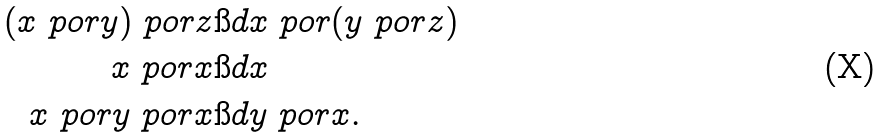<formula> <loc_0><loc_0><loc_500><loc_500>( x \ p o r y ) \ p o r z & \i d x \ p o r ( y \ p o r z ) \\ x \ p o r x & \i d x \\ x \ p o r y \ p o r x & \i d y \ p o r x .</formula> 